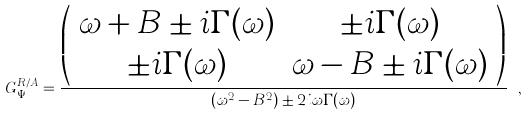<formula> <loc_0><loc_0><loc_500><loc_500>G _ { \Psi } ^ { R / A } = \frac { \left ( \begin{array} { c c } \omega + B \pm i \Gamma ( \omega ) & \pm i \Gamma ( \omega ) \\ \pm i \Gamma ( \omega ) & \omega - B \pm i \Gamma ( \omega ) \end{array} \right ) } { ( \omega ^ { 2 } - B ^ { 2 } ) \pm 2 i \omega \Gamma ( \omega ) } \ ,</formula> 